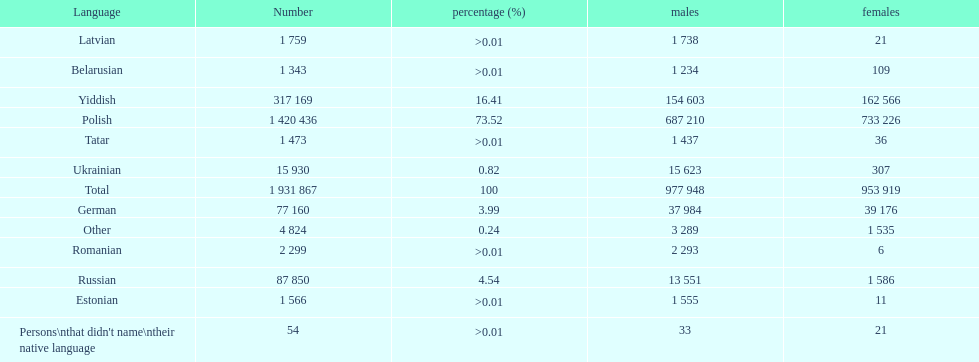Which language had the least female speakers? Romanian. 